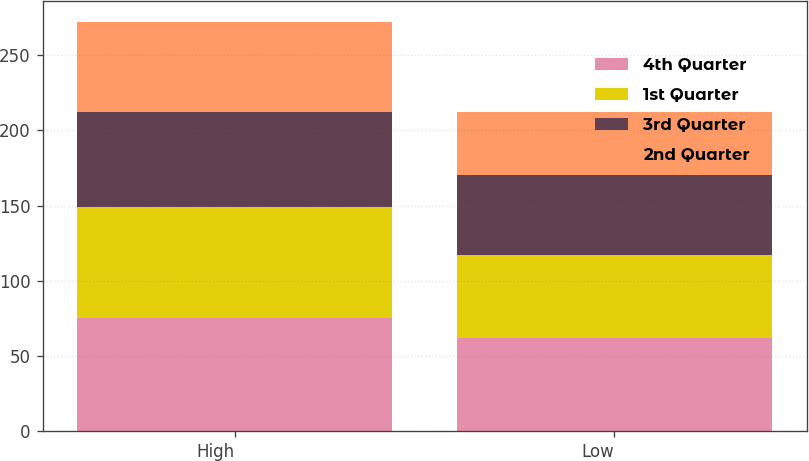<chart> <loc_0><loc_0><loc_500><loc_500><stacked_bar_chart><ecel><fcel>High<fcel>Low<nl><fcel>4th Quarter<fcel>75.4<fcel>61.98<nl><fcel>1st Quarter<fcel>73.76<fcel>55.27<nl><fcel>3rd Quarter<fcel>62.96<fcel>53.46<nl><fcel>2nd Quarter<fcel>60<fcel>41.25<nl></chart> 